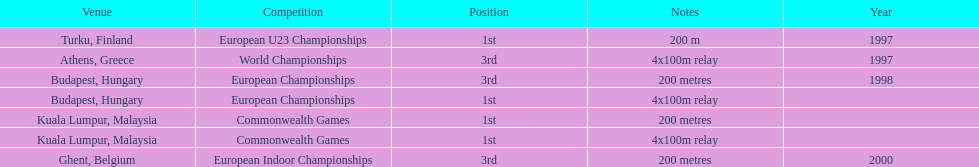How many competitions were in budapest, hungary and came in 1st position? 1. 